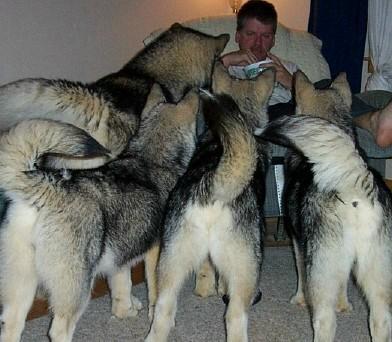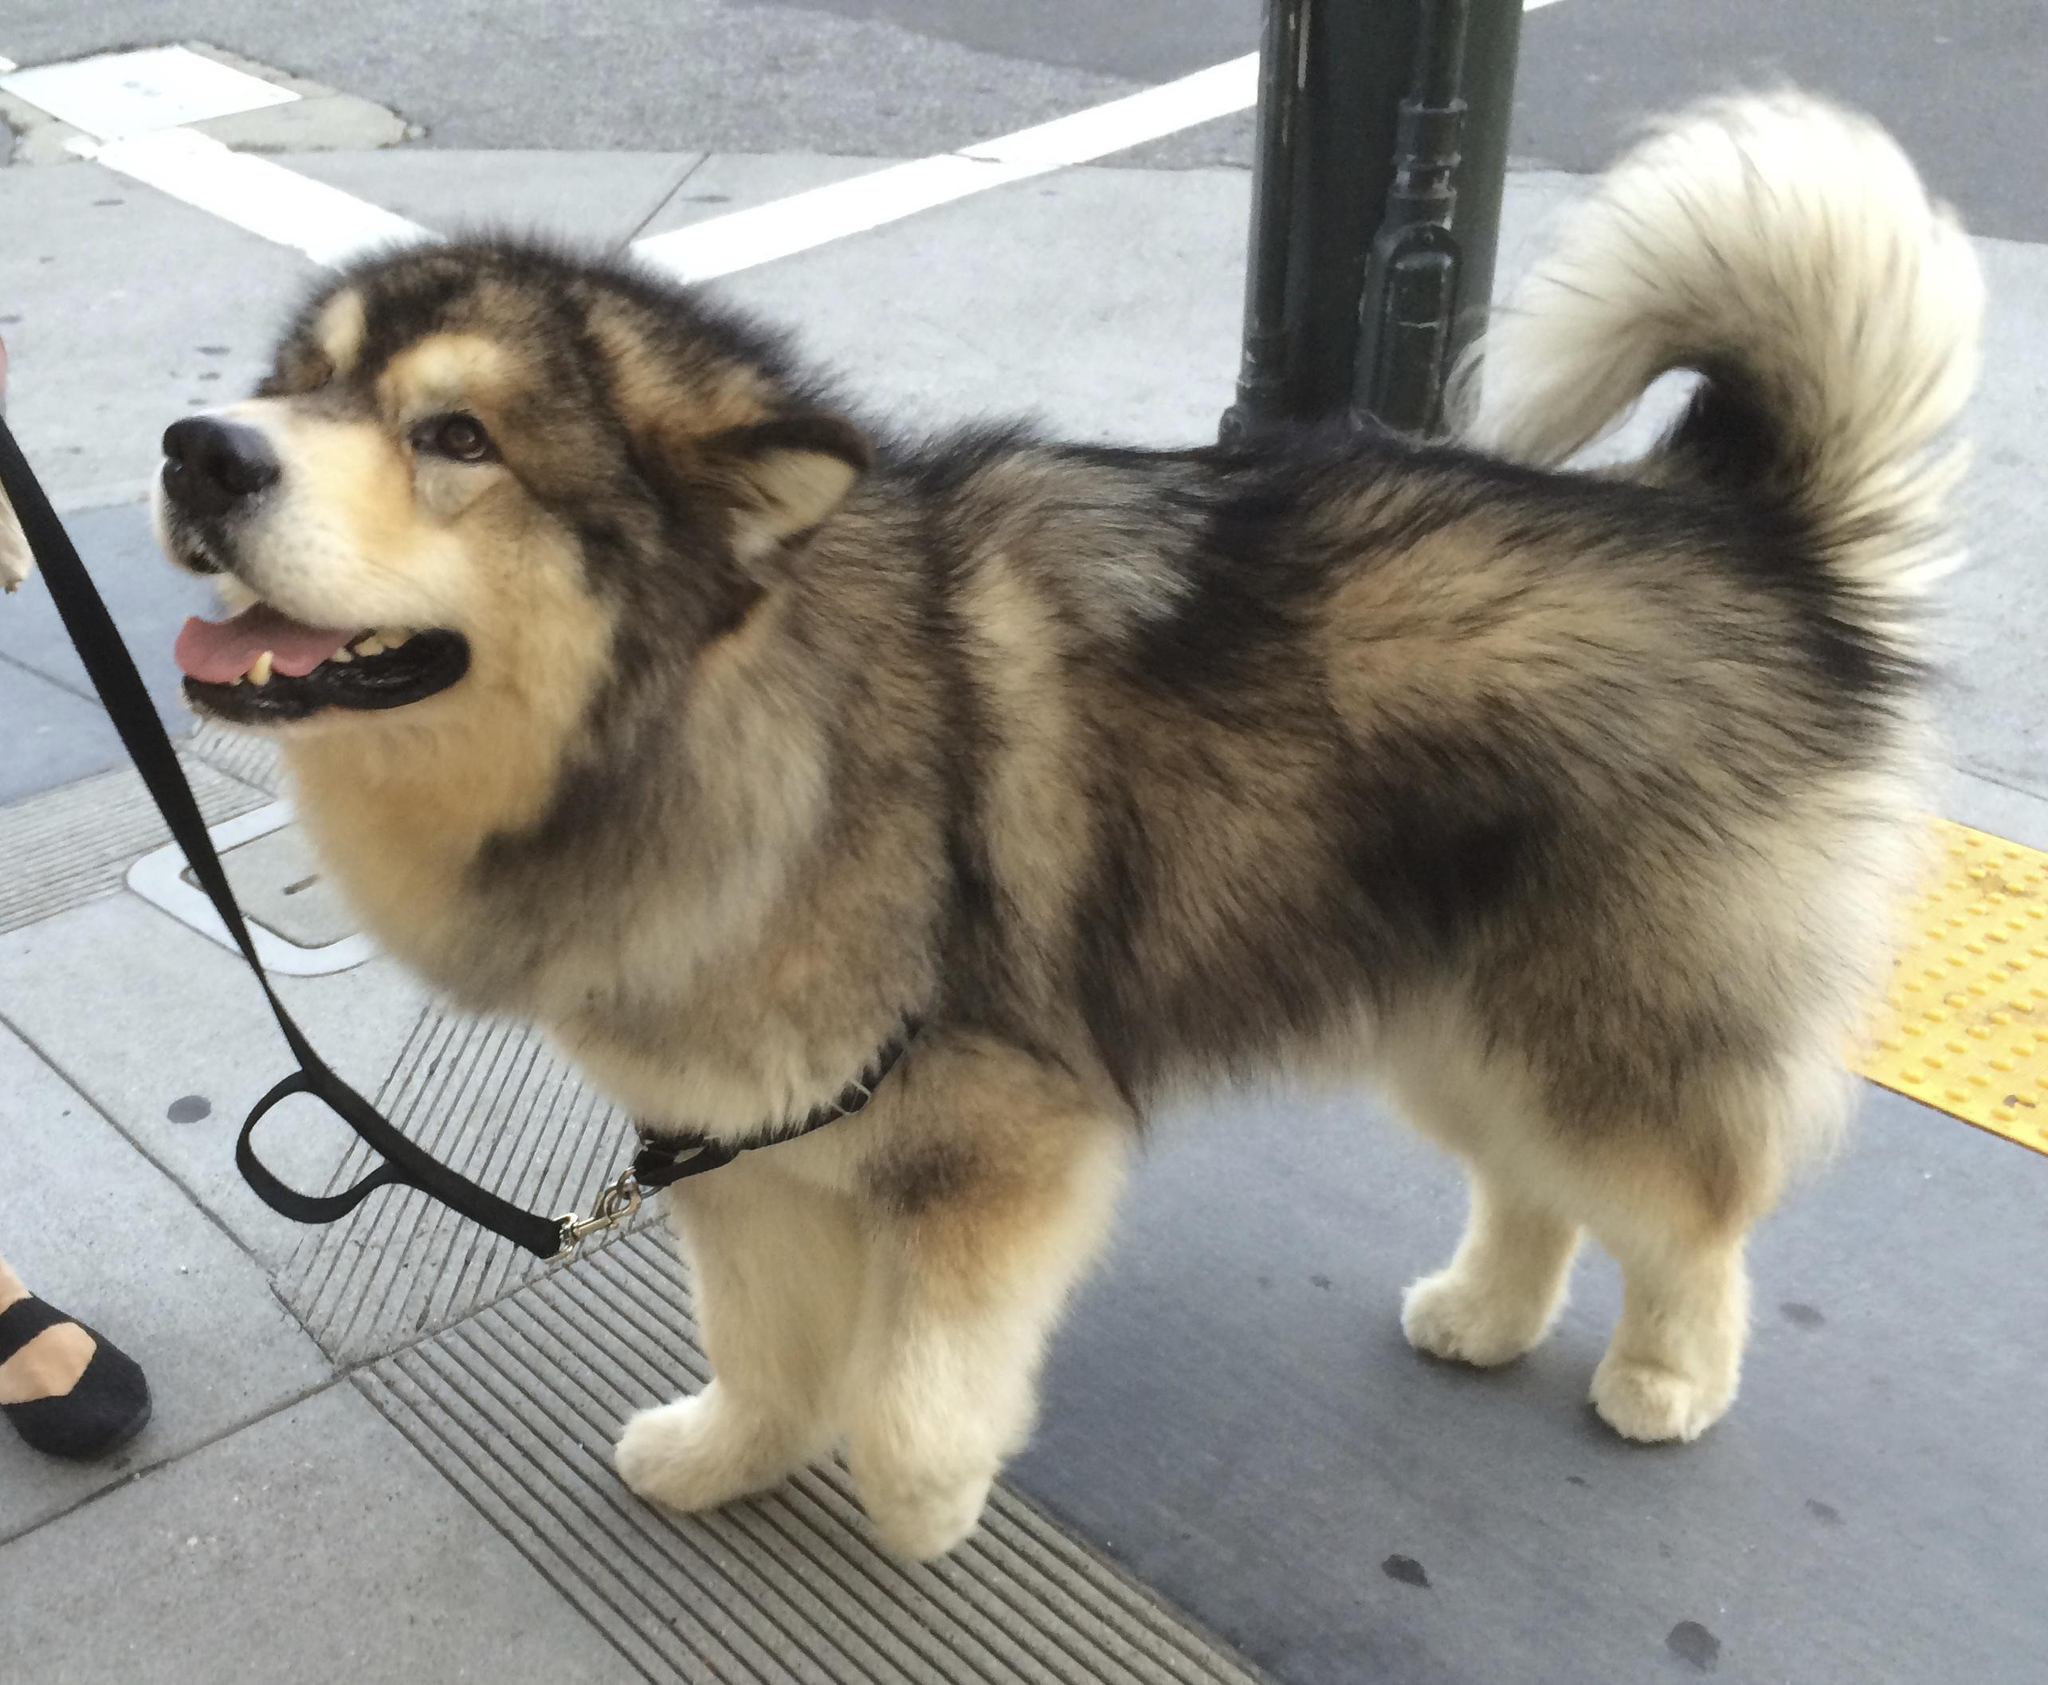The first image is the image on the left, the second image is the image on the right. Examine the images to the left and right. Is the description "The foreground of the right image features an open-mouthed husky with a curled, upturned tail standing in profile facing leftward, withone front paw slightly bent and lifted." accurate? Answer yes or no. Yes. The first image is the image on the left, the second image is the image on the right. Analyze the images presented: Is the assertion "There is a single dog with its mouth open in the right image." valid? Answer yes or no. Yes. 